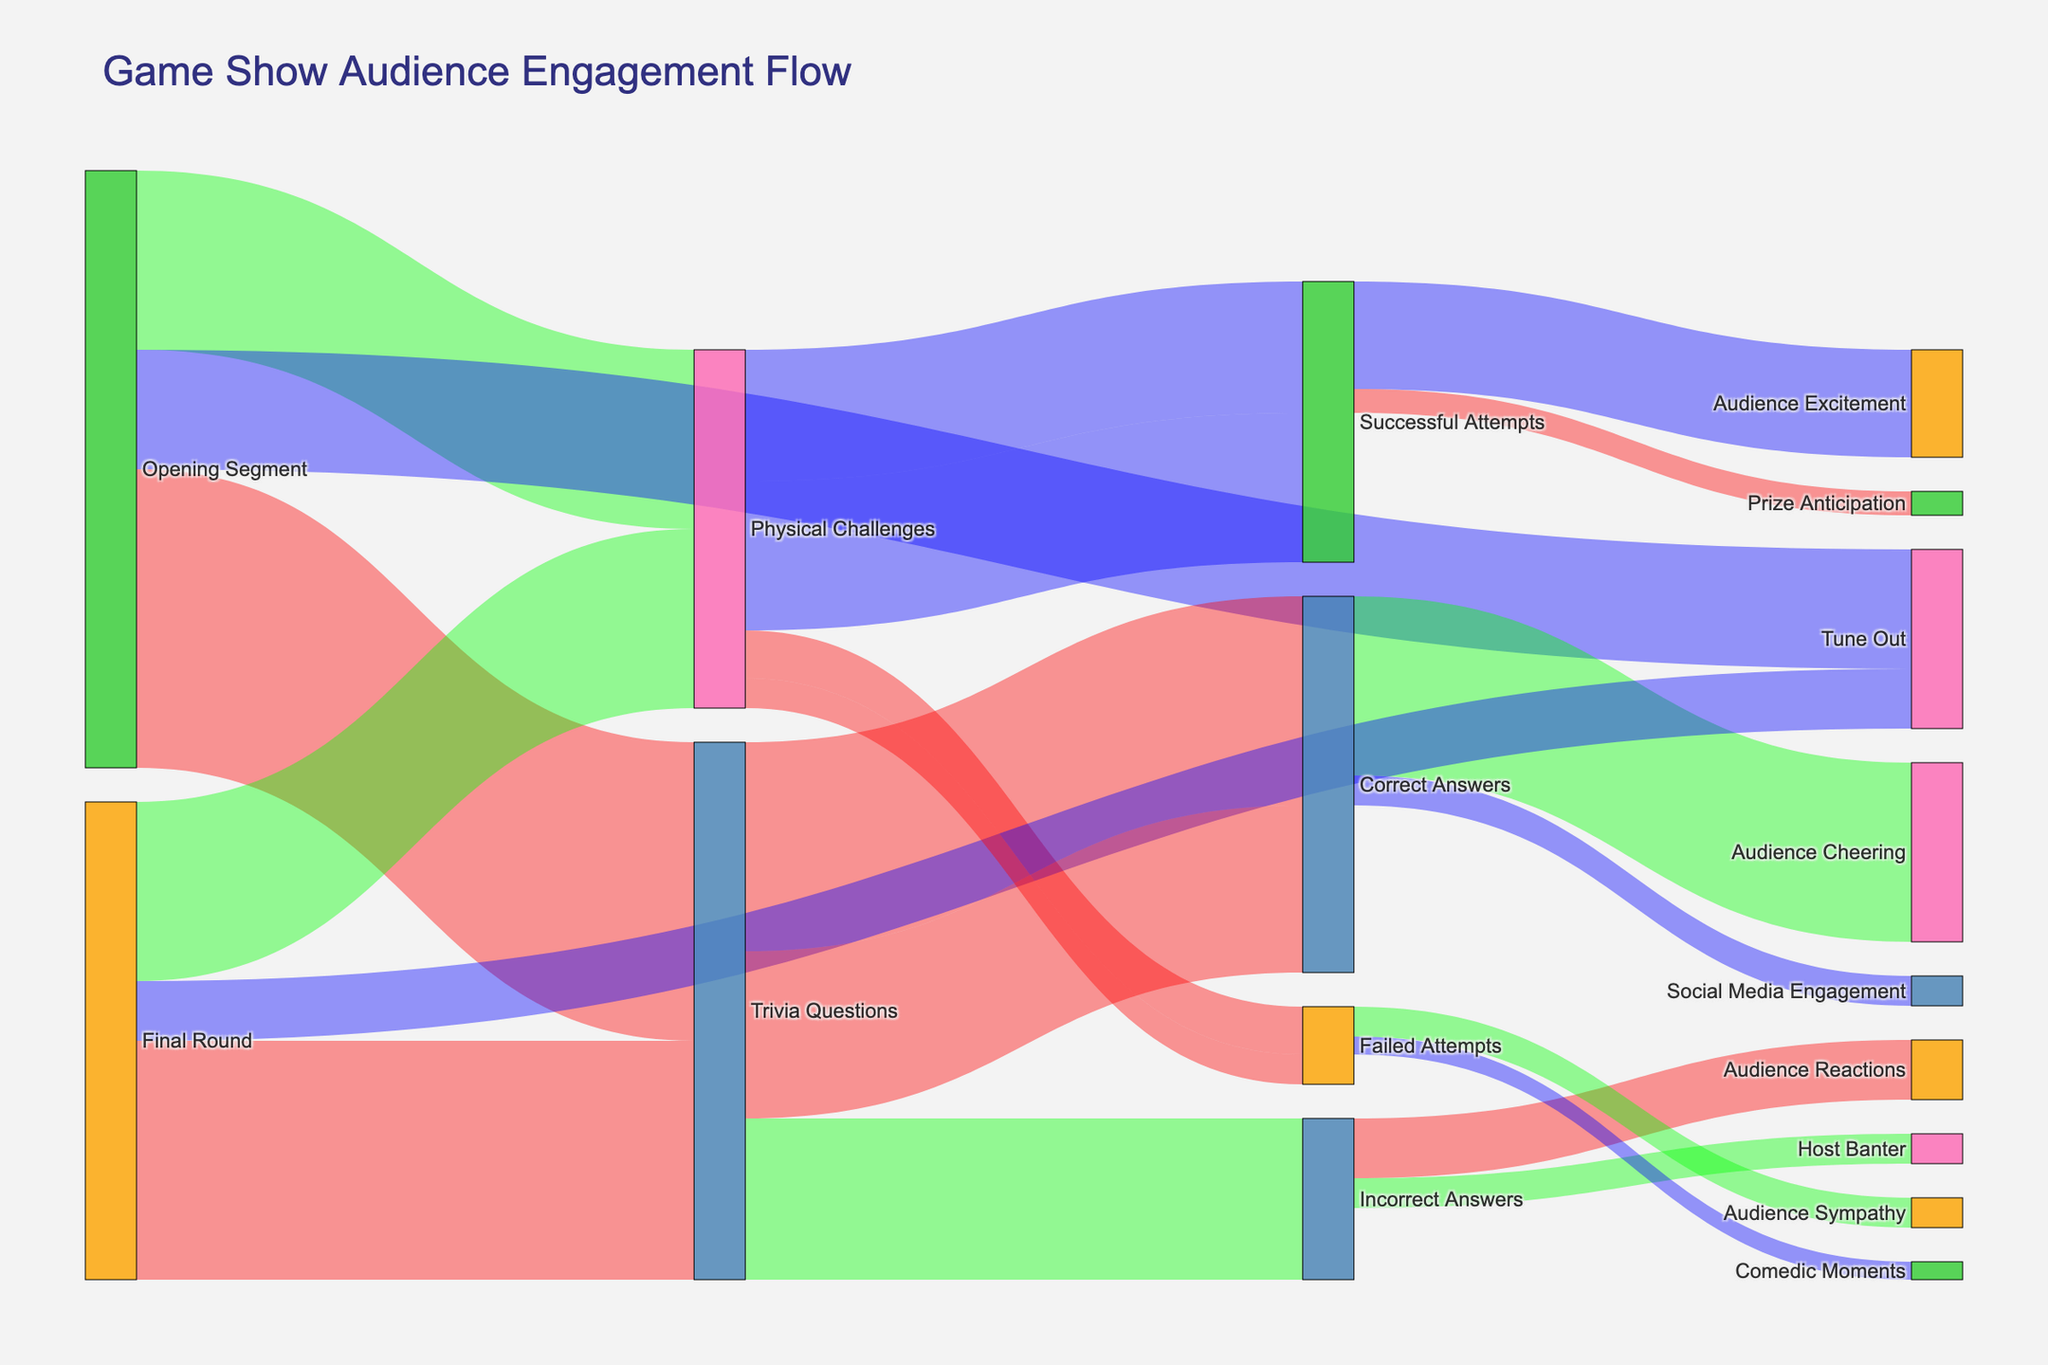What is the title of the Sankey diagram? The title can be found at the top of the Sankey diagram. It summarizes what the diagram is about.
Answer: Game Show Audience Engagement Flow How many audience members tuned out during the Opening Segment? In the diagram, you can see flows from the Opening Segment. Look at the flow labeled "Tune Out" to find the number of audience members.
Answer: 2000 What are the possible outcomes after the audience answers trivia questions? Follow the flow from "Trivia Questions" to see the next segments. You'll find two possible outcomes: "Correct Answers" and "Incorrect Answers".
Answer: Correct Answers, Incorrect Answers How many audience members transitioned from Physical Challenges to Successful Attempts in both the initial and final rounds combined? Sum the values of the flows from "Physical Challenges" to "Successful Attempts" for both the initial (2200) and final rounds (2500).
Answer: 4700 Which segment has the highest engagement after Correct Answers? Check the flow values from "Correct Answers". Compare "Audience Cheering" (3000) and "Social Media Engagement" (500).
Answer: Audience Cheering How much larger is the number of Successful Attempts compared to Failed Attempts in the Final Round? Compare the values for "Successful Attempts" (2500) and "Failed Attempts" (500) under the Final Round. Subtract the smaller number from the larger one.
Answer: 2000 What percentage of the audience cheered after Correct Answers in the initial round of Trivia Questions? First, find the total number of Correct Answers in the initial round (3500). Then, find the number of those who cheered (3000). Divide 3000 by 3500 and multiply by 100 to get the percentage.
Answer: \(\approx\) 85.7% Which segment causes the audience to experience more excitement: Successful Attempts or Prize Anticipation? Investigate the flows from "Successful Attempts": compare "Audience Excitement" (1800) with "Prize Anticipation" (400).
Answer: Audience Excitement How do the audience engagement metrics compare between the Opening Segment and the Final Round for Trivia Questions? Compare the flow values from "Opening Segment" to "Trivia Questions" (5000) with "Final Round" to "Trivia Questions" (4000).
Answer: Opening Segment is higher by 1000 